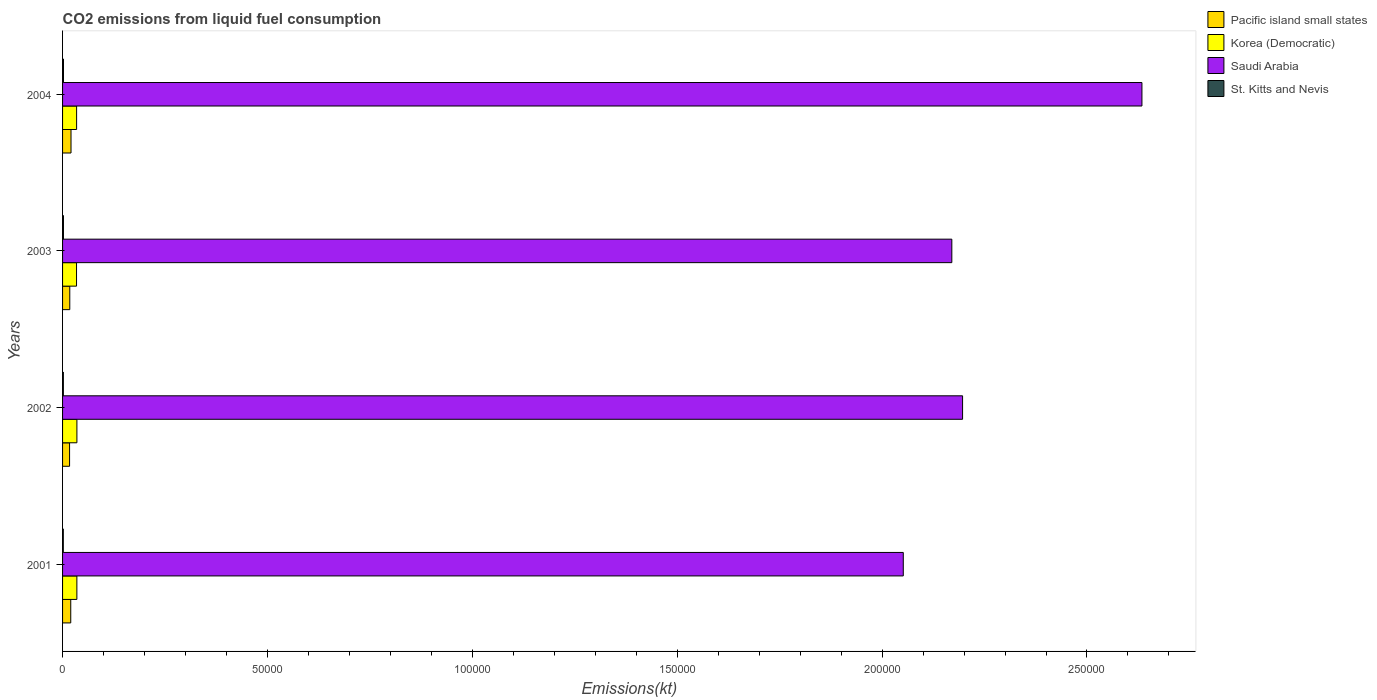Are the number of bars per tick equal to the number of legend labels?
Offer a very short reply. Yes. Are the number of bars on each tick of the Y-axis equal?
Ensure brevity in your answer.  Yes. How many bars are there on the 1st tick from the top?
Provide a short and direct response. 4. How many bars are there on the 1st tick from the bottom?
Make the answer very short. 4. What is the label of the 3rd group of bars from the top?
Offer a terse response. 2002. In how many cases, is the number of bars for a given year not equal to the number of legend labels?
Give a very brief answer. 0. What is the amount of CO2 emitted in St. Kitts and Nevis in 2004?
Offer a terse response. 227.35. Across all years, what is the maximum amount of CO2 emitted in Pacific island small states?
Your answer should be compact. 2060.58. Across all years, what is the minimum amount of CO2 emitted in Korea (Democratic)?
Make the answer very short. 3406.64. In which year was the amount of CO2 emitted in Pacific island small states maximum?
Make the answer very short. 2004. In which year was the amount of CO2 emitted in St. Kitts and Nevis minimum?
Give a very brief answer. 2001. What is the total amount of CO2 emitted in St. Kitts and Nevis in the graph?
Your answer should be compact. 828.74. What is the difference between the amount of CO2 emitted in Pacific island small states in 2003 and that in 2004?
Your answer should be compact. -299.12. What is the difference between the amount of CO2 emitted in Saudi Arabia in 2003 and the amount of CO2 emitted in Korea (Democratic) in 2002?
Give a very brief answer. 2.14e+05. What is the average amount of CO2 emitted in St. Kitts and Nevis per year?
Make the answer very short. 207.19. In the year 2004, what is the difference between the amount of CO2 emitted in St. Kitts and Nevis and amount of CO2 emitted in Saudi Arabia?
Keep it short and to the point. -2.63e+05. In how many years, is the amount of CO2 emitted in Pacific island small states greater than 30000 kt?
Your response must be concise. 0. What is the ratio of the amount of CO2 emitted in Saudi Arabia in 2001 to that in 2003?
Provide a succinct answer. 0.95. Is the difference between the amount of CO2 emitted in St. Kitts and Nevis in 2002 and 2004 greater than the difference between the amount of CO2 emitted in Saudi Arabia in 2002 and 2004?
Ensure brevity in your answer.  Yes. What is the difference between the highest and the second highest amount of CO2 emitted in St. Kitts and Nevis?
Your answer should be very brief. 7.33. What is the difference between the highest and the lowest amount of CO2 emitted in Saudi Arabia?
Offer a very short reply. 5.82e+04. In how many years, is the amount of CO2 emitted in St. Kitts and Nevis greater than the average amount of CO2 emitted in St. Kitts and Nevis taken over all years?
Provide a succinct answer. 2. Is the sum of the amount of CO2 emitted in Saudi Arabia in 2003 and 2004 greater than the maximum amount of CO2 emitted in Korea (Democratic) across all years?
Provide a succinct answer. Yes. Is it the case that in every year, the sum of the amount of CO2 emitted in Pacific island small states and amount of CO2 emitted in Korea (Democratic) is greater than the sum of amount of CO2 emitted in St. Kitts and Nevis and amount of CO2 emitted in Saudi Arabia?
Offer a terse response. No. What does the 1st bar from the top in 2004 represents?
Provide a short and direct response. St. Kitts and Nevis. What does the 3rd bar from the bottom in 2001 represents?
Provide a short and direct response. Saudi Arabia. How many bars are there?
Provide a succinct answer. 16. Are all the bars in the graph horizontal?
Make the answer very short. Yes. How many years are there in the graph?
Make the answer very short. 4. Does the graph contain grids?
Make the answer very short. No. Where does the legend appear in the graph?
Provide a short and direct response. Top right. How are the legend labels stacked?
Your answer should be compact. Vertical. What is the title of the graph?
Provide a succinct answer. CO2 emissions from liquid fuel consumption. What is the label or title of the X-axis?
Provide a succinct answer. Emissions(kt). What is the label or title of the Y-axis?
Ensure brevity in your answer.  Years. What is the Emissions(kt) of Pacific island small states in 2001?
Give a very brief answer. 1997.8. What is the Emissions(kt) in Korea (Democratic) in 2001?
Your answer should be compact. 3490.98. What is the Emissions(kt) in Saudi Arabia in 2001?
Your response must be concise. 2.05e+05. What is the Emissions(kt) in St. Kitts and Nevis in 2001?
Offer a very short reply. 183.35. What is the Emissions(kt) of Pacific island small states in 2002?
Your answer should be very brief. 1709.77. What is the Emissions(kt) in Korea (Democratic) in 2002?
Your answer should be very brief. 3498.32. What is the Emissions(kt) in Saudi Arabia in 2002?
Ensure brevity in your answer.  2.20e+05. What is the Emissions(kt) of St. Kitts and Nevis in 2002?
Your answer should be compact. 198.02. What is the Emissions(kt) in Pacific island small states in 2003?
Your answer should be compact. 1761.47. What is the Emissions(kt) of Korea (Democratic) in 2003?
Give a very brief answer. 3406.64. What is the Emissions(kt) of Saudi Arabia in 2003?
Offer a very short reply. 2.17e+05. What is the Emissions(kt) of St. Kitts and Nevis in 2003?
Give a very brief answer. 220.02. What is the Emissions(kt) in Pacific island small states in 2004?
Ensure brevity in your answer.  2060.58. What is the Emissions(kt) of Korea (Democratic) in 2004?
Your response must be concise. 3428.64. What is the Emissions(kt) of Saudi Arabia in 2004?
Make the answer very short. 2.63e+05. What is the Emissions(kt) in St. Kitts and Nevis in 2004?
Offer a very short reply. 227.35. Across all years, what is the maximum Emissions(kt) of Pacific island small states?
Give a very brief answer. 2060.58. Across all years, what is the maximum Emissions(kt) in Korea (Democratic)?
Your answer should be very brief. 3498.32. Across all years, what is the maximum Emissions(kt) of Saudi Arabia?
Offer a very short reply. 2.63e+05. Across all years, what is the maximum Emissions(kt) of St. Kitts and Nevis?
Offer a terse response. 227.35. Across all years, what is the minimum Emissions(kt) of Pacific island small states?
Provide a succinct answer. 1709.77. Across all years, what is the minimum Emissions(kt) of Korea (Democratic)?
Offer a terse response. 3406.64. Across all years, what is the minimum Emissions(kt) in Saudi Arabia?
Your response must be concise. 2.05e+05. Across all years, what is the minimum Emissions(kt) of St. Kitts and Nevis?
Offer a terse response. 183.35. What is the total Emissions(kt) in Pacific island small states in the graph?
Your response must be concise. 7529.62. What is the total Emissions(kt) of Korea (Democratic) in the graph?
Provide a succinct answer. 1.38e+04. What is the total Emissions(kt) in Saudi Arabia in the graph?
Ensure brevity in your answer.  9.05e+05. What is the total Emissions(kt) in St. Kitts and Nevis in the graph?
Ensure brevity in your answer.  828.74. What is the difference between the Emissions(kt) in Pacific island small states in 2001 and that in 2002?
Your answer should be compact. 288.04. What is the difference between the Emissions(kt) in Korea (Democratic) in 2001 and that in 2002?
Provide a short and direct response. -7.33. What is the difference between the Emissions(kt) of Saudi Arabia in 2001 and that in 2002?
Make the answer very short. -1.45e+04. What is the difference between the Emissions(kt) in St. Kitts and Nevis in 2001 and that in 2002?
Provide a succinct answer. -14.67. What is the difference between the Emissions(kt) of Pacific island small states in 2001 and that in 2003?
Make the answer very short. 236.34. What is the difference between the Emissions(kt) in Korea (Democratic) in 2001 and that in 2003?
Provide a succinct answer. 84.34. What is the difference between the Emissions(kt) of Saudi Arabia in 2001 and that in 2003?
Give a very brief answer. -1.18e+04. What is the difference between the Emissions(kt) in St. Kitts and Nevis in 2001 and that in 2003?
Offer a very short reply. -36.67. What is the difference between the Emissions(kt) of Pacific island small states in 2001 and that in 2004?
Your answer should be compact. -62.78. What is the difference between the Emissions(kt) in Korea (Democratic) in 2001 and that in 2004?
Your answer should be compact. 62.34. What is the difference between the Emissions(kt) in Saudi Arabia in 2001 and that in 2004?
Offer a terse response. -5.82e+04. What is the difference between the Emissions(kt) in St. Kitts and Nevis in 2001 and that in 2004?
Give a very brief answer. -44. What is the difference between the Emissions(kt) in Pacific island small states in 2002 and that in 2003?
Offer a terse response. -51.7. What is the difference between the Emissions(kt) of Korea (Democratic) in 2002 and that in 2003?
Offer a very short reply. 91.67. What is the difference between the Emissions(kt) of Saudi Arabia in 2002 and that in 2003?
Provide a succinct answer. 2625.57. What is the difference between the Emissions(kt) of St. Kitts and Nevis in 2002 and that in 2003?
Keep it short and to the point. -22. What is the difference between the Emissions(kt) of Pacific island small states in 2002 and that in 2004?
Your response must be concise. -350.82. What is the difference between the Emissions(kt) of Korea (Democratic) in 2002 and that in 2004?
Provide a succinct answer. 69.67. What is the difference between the Emissions(kt) of Saudi Arabia in 2002 and that in 2004?
Your response must be concise. -4.38e+04. What is the difference between the Emissions(kt) of St. Kitts and Nevis in 2002 and that in 2004?
Keep it short and to the point. -29.34. What is the difference between the Emissions(kt) in Pacific island small states in 2003 and that in 2004?
Provide a succinct answer. -299.12. What is the difference between the Emissions(kt) in Korea (Democratic) in 2003 and that in 2004?
Provide a short and direct response. -22. What is the difference between the Emissions(kt) in Saudi Arabia in 2003 and that in 2004?
Give a very brief answer. -4.64e+04. What is the difference between the Emissions(kt) in St. Kitts and Nevis in 2003 and that in 2004?
Provide a succinct answer. -7.33. What is the difference between the Emissions(kt) of Pacific island small states in 2001 and the Emissions(kt) of Korea (Democratic) in 2002?
Provide a short and direct response. -1500.51. What is the difference between the Emissions(kt) in Pacific island small states in 2001 and the Emissions(kt) in Saudi Arabia in 2002?
Offer a very short reply. -2.18e+05. What is the difference between the Emissions(kt) of Pacific island small states in 2001 and the Emissions(kt) of St. Kitts and Nevis in 2002?
Your answer should be very brief. 1799.79. What is the difference between the Emissions(kt) in Korea (Democratic) in 2001 and the Emissions(kt) in Saudi Arabia in 2002?
Your response must be concise. -2.16e+05. What is the difference between the Emissions(kt) of Korea (Democratic) in 2001 and the Emissions(kt) of St. Kitts and Nevis in 2002?
Give a very brief answer. 3292.97. What is the difference between the Emissions(kt) in Saudi Arabia in 2001 and the Emissions(kt) in St. Kitts and Nevis in 2002?
Provide a short and direct response. 2.05e+05. What is the difference between the Emissions(kt) of Pacific island small states in 2001 and the Emissions(kt) of Korea (Democratic) in 2003?
Keep it short and to the point. -1408.84. What is the difference between the Emissions(kt) in Pacific island small states in 2001 and the Emissions(kt) in Saudi Arabia in 2003?
Offer a very short reply. -2.15e+05. What is the difference between the Emissions(kt) in Pacific island small states in 2001 and the Emissions(kt) in St. Kitts and Nevis in 2003?
Offer a very short reply. 1777.78. What is the difference between the Emissions(kt) of Korea (Democratic) in 2001 and the Emissions(kt) of Saudi Arabia in 2003?
Ensure brevity in your answer.  -2.14e+05. What is the difference between the Emissions(kt) in Korea (Democratic) in 2001 and the Emissions(kt) in St. Kitts and Nevis in 2003?
Provide a succinct answer. 3270.96. What is the difference between the Emissions(kt) of Saudi Arabia in 2001 and the Emissions(kt) of St. Kitts and Nevis in 2003?
Keep it short and to the point. 2.05e+05. What is the difference between the Emissions(kt) of Pacific island small states in 2001 and the Emissions(kt) of Korea (Democratic) in 2004?
Offer a very short reply. -1430.84. What is the difference between the Emissions(kt) of Pacific island small states in 2001 and the Emissions(kt) of Saudi Arabia in 2004?
Offer a terse response. -2.61e+05. What is the difference between the Emissions(kt) in Pacific island small states in 2001 and the Emissions(kt) in St. Kitts and Nevis in 2004?
Give a very brief answer. 1770.45. What is the difference between the Emissions(kt) of Korea (Democratic) in 2001 and the Emissions(kt) of Saudi Arabia in 2004?
Provide a succinct answer. -2.60e+05. What is the difference between the Emissions(kt) in Korea (Democratic) in 2001 and the Emissions(kt) in St. Kitts and Nevis in 2004?
Provide a succinct answer. 3263.63. What is the difference between the Emissions(kt) of Saudi Arabia in 2001 and the Emissions(kt) of St. Kitts and Nevis in 2004?
Offer a very short reply. 2.05e+05. What is the difference between the Emissions(kt) in Pacific island small states in 2002 and the Emissions(kt) in Korea (Democratic) in 2003?
Keep it short and to the point. -1696.88. What is the difference between the Emissions(kt) in Pacific island small states in 2002 and the Emissions(kt) in Saudi Arabia in 2003?
Offer a terse response. -2.15e+05. What is the difference between the Emissions(kt) of Pacific island small states in 2002 and the Emissions(kt) of St. Kitts and Nevis in 2003?
Make the answer very short. 1489.75. What is the difference between the Emissions(kt) in Korea (Democratic) in 2002 and the Emissions(kt) in Saudi Arabia in 2003?
Offer a very short reply. -2.14e+05. What is the difference between the Emissions(kt) of Korea (Democratic) in 2002 and the Emissions(kt) of St. Kitts and Nevis in 2003?
Your answer should be very brief. 3278.3. What is the difference between the Emissions(kt) of Saudi Arabia in 2002 and the Emissions(kt) of St. Kitts and Nevis in 2003?
Provide a short and direct response. 2.19e+05. What is the difference between the Emissions(kt) of Pacific island small states in 2002 and the Emissions(kt) of Korea (Democratic) in 2004?
Keep it short and to the point. -1718.88. What is the difference between the Emissions(kt) of Pacific island small states in 2002 and the Emissions(kt) of Saudi Arabia in 2004?
Your response must be concise. -2.62e+05. What is the difference between the Emissions(kt) in Pacific island small states in 2002 and the Emissions(kt) in St. Kitts and Nevis in 2004?
Offer a very short reply. 1482.41. What is the difference between the Emissions(kt) in Korea (Democratic) in 2002 and the Emissions(kt) in Saudi Arabia in 2004?
Your answer should be compact. -2.60e+05. What is the difference between the Emissions(kt) in Korea (Democratic) in 2002 and the Emissions(kt) in St. Kitts and Nevis in 2004?
Provide a succinct answer. 3270.96. What is the difference between the Emissions(kt) in Saudi Arabia in 2002 and the Emissions(kt) in St. Kitts and Nevis in 2004?
Keep it short and to the point. 2.19e+05. What is the difference between the Emissions(kt) in Pacific island small states in 2003 and the Emissions(kt) in Korea (Democratic) in 2004?
Your answer should be very brief. -1667.18. What is the difference between the Emissions(kt) in Pacific island small states in 2003 and the Emissions(kt) in Saudi Arabia in 2004?
Your answer should be compact. -2.62e+05. What is the difference between the Emissions(kt) of Pacific island small states in 2003 and the Emissions(kt) of St. Kitts and Nevis in 2004?
Keep it short and to the point. 1534.11. What is the difference between the Emissions(kt) in Korea (Democratic) in 2003 and the Emissions(kt) in Saudi Arabia in 2004?
Provide a succinct answer. -2.60e+05. What is the difference between the Emissions(kt) in Korea (Democratic) in 2003 and the Emissions(kt) in St. Kitts and Nevis in 2004?
Your response must be concise. 3179.29. What is the difference between the Emissions(kt) of Saudi Arabia in 2003 and the Emissions(kt) of St. Kitts and Nevis in 2004?
Your answer should be very brief. 2.17e+05. What is the average Emissions(kt) of Pacific island small states per year?
Your answer should be very brief. 1882.4. What is the average Emissions(kt) in Korea (Democratic) per year?
Provide a short and direct response. 3456.15. What is the average Emissions(kt) of Saudi Arabia per year?
Your response must be concise. 2.26e+05. What is the average Emissions(kt) in St. Kitts and Nevis per year?
Give a very brief answer. 207.19. In the year 2001, what is the difference between the Emissions(kt) of Pacific island small states and Emissions(kt) of Korea (Democratic)?
Offer a terse response. -1493.18. In the year 2001, what is the difference between the Emissions(kt) of Pacific island small states and Emissions(kt) of Saudi Arabia?
Your answer should be very brief. -2.03e+05. In the year 2001, what is the difference between the Emissions(kt) of Pacific island small states and Emissions(kt) of St. Kitts and Nevis?
Offer a terse response. 1814.45. In the year 2001, what is the difference between the Emissions(kt) in Korea (Democratic) and Emissions(kt) in Saudi Arabia?
Ensure brevity in your answer.  -2.02e+05. In the year 2001, what is the difference between the Emissions(kt) in Korea (Democratic) and Emissions(kt) in St. Kitts and Nevis?
Ensure brevity in your answer.  3307.63. In the year 2001, what is the difference between the Emissions(kt) of Saudi Arabia and Emissions(kt) of St. Kitts and Nevis?
Give a very brief answer. 2.05e+05. In the year 2002, what is the difference between the Emissions(kt) of Pacific island small states and Emissions(kt) of Korea (Democratic)?
Your answer should be compact. -1788.55. In the year 2002, what is the difference between the Emissions(kt) of Pacific island small states and Emissions(kt) of Saudi Arabia?
Make the answer very short. -2.18e+05. In the year 2002, what is the difference between the Emissions(kt) in Pacific island small states and Emissions(kt) in St. Kitts and Nevis?
Your answer should be very brief. 1511.75. In the year 2002, what is the difference between the Emissions(kt) of Korea (Democratic) and Emissions(kt) of Saudi Arabia?
Offer a terse response. -2.16e+05. In the year 2002, what is the difference between the Emissions(kt) in Korea (Democratic) and Emissions(kt) in St. Kitts and Nevis?
Offer a terse response. 3300.3. In the year 2002, what is the difference between the Emissions(kt) of Saudi Arabia and Emissions(kt) of St. Kitts and Nevis?
Your answer should be compact. 2.19e+05. In the year 2003, what is the difference between the Emissions(kt) in Pacific island small states and Emissions(kt) in Korea (Democratic)?
Offer a very short reply. -1645.18. In the year 2003, what is the difference between the Emissions(kt) in Pacific island small states and Emissions(kt) in Saudi Arabia?
Offer a very short reply. -2.15e+05. In the year 2003, what is the difference between the Emissions(kt) of Pacific island small states and Emissions(kt) of St. Kitts and Nevis?
Offer a very short reply. 1541.45. In the year 2003, what is the difference between the Emissions(kt) in Korea (Democratic) and Emissions(kt) in Saudi Arabia?
Make the answer very short. -2.14e+05. In the year 2003, what is the difference between the Emissions(kt) in Korea (Democratic) and Emissions(kt) in St. Kitts and Nevis?
Offer a very short reply. 3186.62. In the year 2003, what is the difference between the Emissions(kt) of Saudi Arabia and Emissions(kt) of St. Kitts and Nevis?
Ensure brevity in your answer.  2.17e+05. In the year 2004, what is the difference between the Emissions(kt) in Pacific island small states and Emissions(kt) in Korea (Democratic)?
Your answer should be very brief. -1368.06. In the year 2004, what is the difference between the Emissions(kt) in Pacific island small states and Emissions(kt) in Saudi Arabia?
Make the answer very short. -2.61e+05. In the year 2004, what is the difference between the Emissions(kt) in Pacific island small states and Emissions(kt) in St. Kitts and Nevis?
Provide a short and direct response. 1833.23. In the year 2004, what is the difference between the Emissions(kt) of Korea (Democratic) and Emissions(kt) of Saudi Arabia?
Your answer should be compact. -2.60e+05. In the year 2004, what is the difference between the Emissions(kt) in Korea (Democratic) and Emissions(kt) in St. Kitts and Nevis?
Provide a succinct answer. 3201.29. In the year 2004, what is the difference between the Emissions(kt) in Saudi Arabia and Emissions(kt) in St. Kitts and Nevis?
Your answer should be compact. 2.63e+05. What is the ratio of the Emissions(kt) of Pacific island small states in 2001 to that in 2002?
Your answer should be compact. 1.17. What is the ratio of the Emissions(kt) in Saudi Arabia in 2001 to that in 2002?
Your response must be concise. 0.93. What is the ratio of the Emissions(kt) of St. Kitts and Nevis in 2001 to that in 2002?
Your answer should be compact. 0.93. What is the ratio of the Emissions(kt) in Pacific island small states in 2001 to that in 2003?
Offer a terse response. 1.13. What is the ratio of the Emissions(kt) of Korea (Democratic) in 2001 to that in 2003?
Offer a very short reply. 1.02. What is the ratio of the Emissions(kt) of Saudi Arabia in 2001 to that in 2003?
Offer a terse response. 0.95. What is the ratio of the Emissions(kt) in Pacific island small states in 2001 to that in 2004?
Your response must be concise. 0.97. What is the ratio of the Emissions(kt) of Korea (Democratic) in 2001 to that in 2004?
Your answer should be very brief. 1.02. What is the ratio of the Emissions(kt) in Saudi Arabia in 2001 to that in 2004?
Make the answer very short. 0.78. What is the ratio of the Emissions(kt) in St. Kitts and Nevis in 2001 to that in 2004?
Provide a short and direct response. 0.81. What is the ratio of the Emissions(kt) in Pacific island small states in 2002 to that in 2003?
Provide a succinct answer. 0.97. What is the ratio of the Emissions(kt) of Korea (Democratic) in 2002 to that in 2003?
Ensure brevity in your answer.  1.03. What is the ratio of the Emissions(kt) in Saudi Arabia in 2002 to that in 2003?
Offer a very short reply. 1.01. What is the ratio of the Emissions(kt) in St. Kitts and Nevis in 2002 to that in 2003?
Provide a short and direct response. 0.9. What is the ratio of the Emissions(kt) of Pacific island small states in 2002 to that in 2004?
Provide a short and direct response. 0.83. What is the ratio of the Emissions(kt) in Korea (Democratic) in 2002 to that in 2004?
Give a very brief answer. 1.02. What is the ratio of the Emissions(kt) of Saudi Arabia in 2002 to that in 2004?
Your answer should be very brief. 0.83. What is the ratio of the Emissions(kt) in St. Kitts and Nevis in 2002 to that in 2004?
Your response must be concise. 0.87. What is the ratio of the Emissions(kt) of Pacific island small states in 2003 to that in 2004?
Offer a terse response. 0.85. What is the ratio of the Emissions(kt) in Saudi Arabia in 2003 to that in 2004?
Make the answer very short. 0.82. What is the ratio of the Emissions(kt) in St. Kitts and Nevis in 2003 to that in 2004?
Your response must be concise. 0.97. What is the difference between the highest and the second highest Emissions(kt) of Pacific island small states?
Offer a terse response. 62.78. What is the difference between the highest and the second highest Emissions(kt) in Korea (Democratic)?
Ensure brevity in your answer.  7.33. What is the difference between the highest and the second highest Emissions(kt) in Saudi Arabia?
Your answer should be compact. 4.38e+04. What is the difference between the highest and the second highest Emissions(kt) in St. Kitts and Nevis?
Provide a short and direct response. 7.33. What is the difference between the highest and the lowest Emissions(kt) in Pacific island small states?
Offer a very short reply. 350.82. What is the difference between the highest and the lowest Emissions(kt) in Korea (Democratic)?
Provide a succinct answer. 91.67. What is the difference between the highest and the lowest Emissions(kt) in Saudi Arabia?
Offer a terse response. 5.82e+04. What is the difference between the highest and the lowest Emissions(kt) of St. Kitts and Nevis?
Keep it short and to the point. 44. 